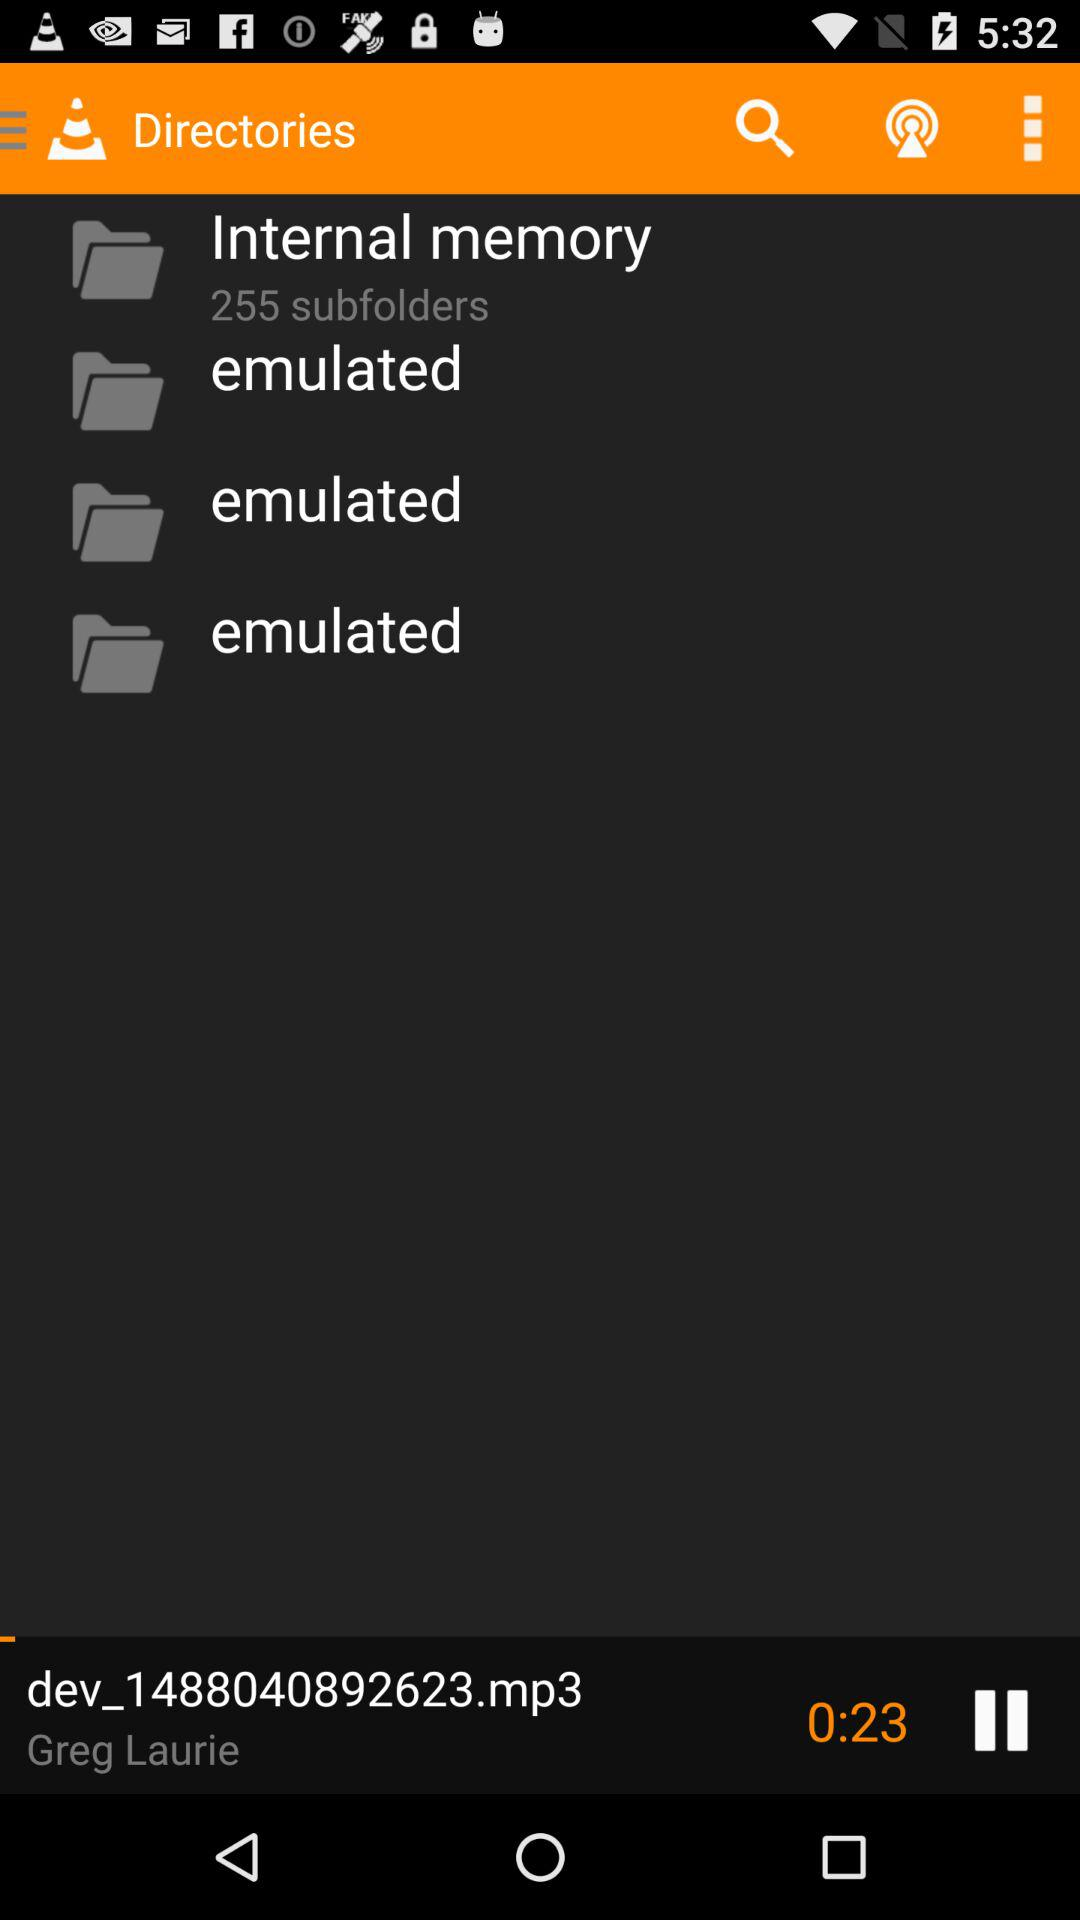Which audio is playing? The audio is "dev_1488040892623.mp3". 